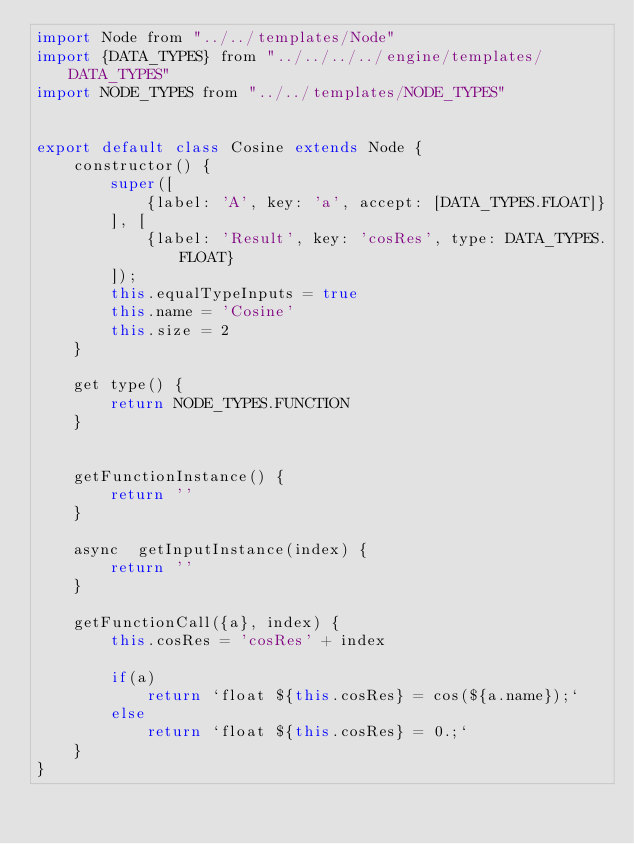<code> <loc_0><loc_0><loc_500><loc_500><_JavaScript_>import Node from "../../templates/Node"
import {DATA_TYPES} from "../../../../engine/templates/DATA_TYPES"
import NODE_TYPES from "../../templates/NODE_TYPES"


export default class Cosine extends Node {
    constructor() {
        super([
            {label: 'A', key: 'a', accept: [DATA_TYPES.FLOAT]}
        ], [
            {label: 'Result', key: 'cosRes', type: DATA_TYPES.FLOAT}
        ]);
        this.equalTypeInputs = true
        this.name = 'Cosine'
        this.size = 2
    }

    get type() {
        return NODE_TYPES.FUNCTION
    }


    getFunctionInstance() {
        return ''
    }

    async  getInputInstance(index) {
        return ''
    }

    getFunctionCall({a}, index) {
        this.cosRes = 'cosRes' + index

        if(a)
            return `float ${this.cosRes} = cos(${a.name});`
        else
            return `float ${this.cosRes} = 0.;`
    }
}</code> 